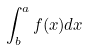<formula> <loc_0><loc_0><loc_500><loc_500>\int _ { b } ^ { a } f ( x ) d x</formula> 